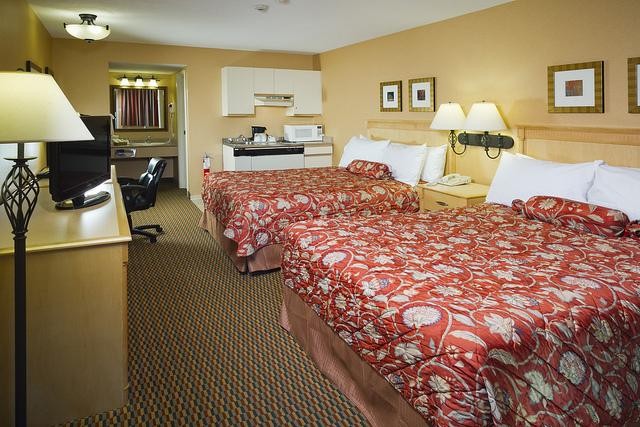Who would stay in this room?

Choices:
A) resident
B) prisoner
C) maid
D) traveler traveler 